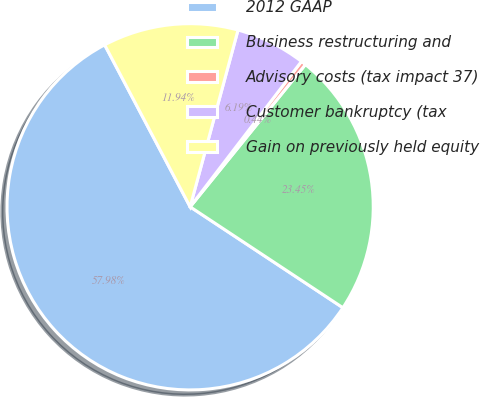Convert chart. <chart><loc_0><loc_0><loc_500><loc_500><pie_chart><fcel>2012 GAAP<fcel>Business restructuring and<fcel>Advisory costs (tax impact 37)<fcel>Customer bankruptcy (tax<fcel>Gain on previously held equity<nl><fcel>57.98%<fcel>23.45%<fcel>0.44%<fcel>6.19%<fcel>11.94%<nl></chart> 